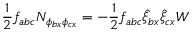Convert formula to latex. <formula><loc_0><loc_0><loc_500><loc_500>\frac { 1 } { 2 } f _ { a b c } N _ { \phi _ { b x } \phi _ { c x } } = - \frac { 1 } { 2 } f _ { a b c } \hat { \xi } _ { b x } \hat { \xi } _ { c x } W</formula> 